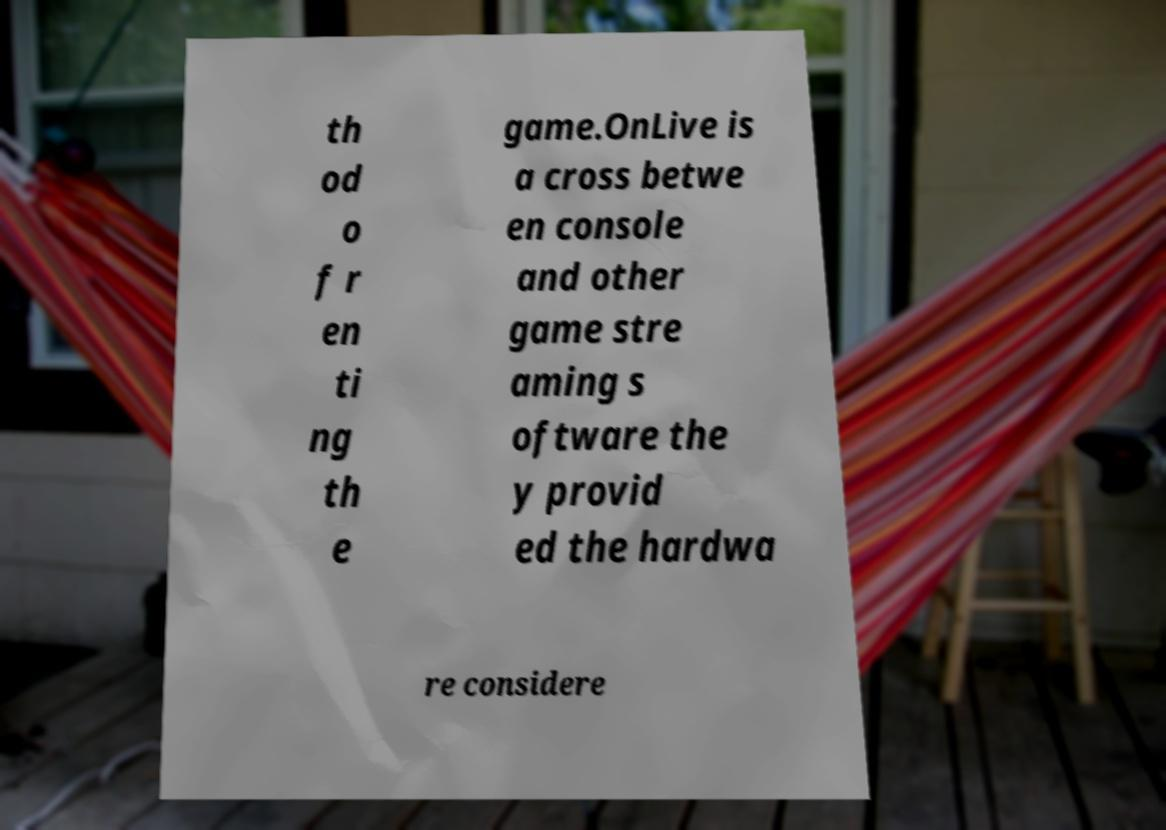What messages or text are displayed in this image? I need them in a readable, typed format. th od o f r en ti ng th e game.OnLive is a cross betwe en console and other game stre aming s oftware the y provid ed the hardwa re considere 